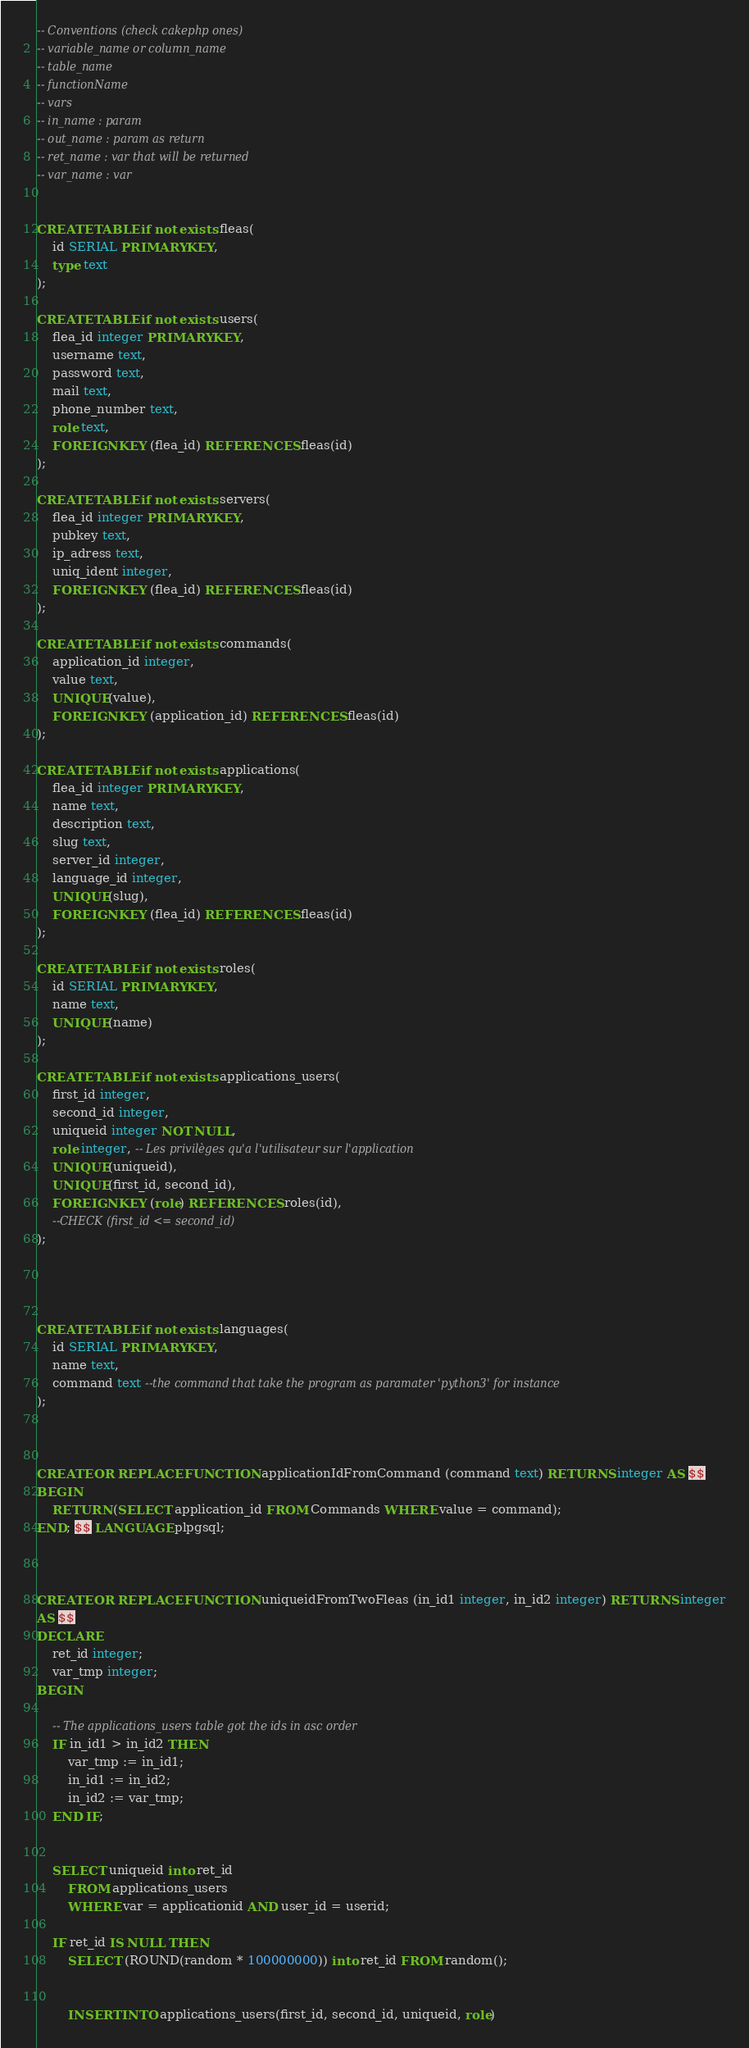<code> <loc_0><loc_0><loc_500><loc_500><_SQL_>-- Conventions (check cakephp ones)
-- variable_name or column_name
-- table_name
-- functionName
-- vars
-- in_name : param
-- out_name : param as return
-- ret_name : var that will be returned
-- var_name : var


CREATE TABLE if not exists fleas(
	id SERIAL PRIMARY KEY,
	type text
);

CREATE TABLE if not exists users(
	flea_id integer PRIMARY KEY,
	username text,
	password text,
	mail text,
	phone_number text,
	role text,
	FOREIGN KEY (flea_id) REFERENCES fleas(id)
);

CREATE TABLE if not exists servers(
	flea_id integer PRIMARY KEY,
	pubkey text,
	ip_adress text,
	uniq_ident integer,
	FOREIGN KEY (flea_id) REFERENCES fleas(id)
);

CREATE TABLE if not exists commands(
	application_id integer,
	value text,
	UNIQUE(value),
	FOREIGN KEY (application_id) REFERENCES fleas(id)
);

CREATE TABLE if not exists applications(
	flea_id integer PRIMARY KEY,
	name text,
	description text,
	slug text,
	server_id integer,
	language_id integer,
	UNIQUE(slug),
	FOREIGN KEY (flea_id) REFERENCES fleas(id)
);

CREATE TABLE if not exists roles(
	id SERIAL PRIMARY KEY,
	name text,
	UNIQUE(name)
);

CREATE TABLE if not exists applications_users(
	first_id integer,
	second_id integer,
	uniqueid integer NOT NULL,
	role integer, -- Les privilèges qu'a l'utilisateur sur l'application
	UNIQUE(uniqueid),
	UNIQUE(first_id, second_id),
	FOREIGN KEY (role) REFERENCES roles(id),
	--CHECK (first_id <= second_id)
);




CREATE TABLE if not exists languages(
	id SERIAL PRIMARY KEY,
	name text,
	command text --the command that take the program as paramater 'python3' for instance
);



CREATE OR REPLACE FUNCTION applicationIdFromCommand (command text) RETURNS integer AS $$
BEGIN
	RETURN (SELECT application_id FROM Commands WHERE value = command);
END; $$ LANGUAGE plpgsql;



CREATE OR REPLACE FUNCTION uniqueidFromTwoFleas (in_id1 integer, in_id2 integer) RETURNS integer
AS $$
DECLARE
	ret_id integer;
	var_tmp integer;
BEGIN

	-- The applications_users table got the ids in asc order
	IF in_id1 > in_id2 THEN
		var_tmp := in_id1;
		in_id1 := in_id2;
		in_id2 := var_tmp;
	END IF;


	SELECT uniqueid into ret_id
		FROM applications_users 
		WHERE var = applicationid AND user_id = userid;

	IF ret_id IS NULL THEN
		SELECT (ROUND(random * 100000000)) into ret_id FROM random();


		INSERT INTO applications_users(first_id, second_id, uniqueid, role)</code> 